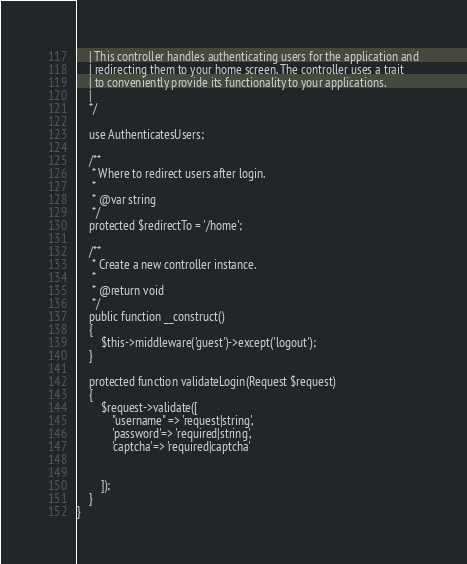Convert code to text. <code><loc_0><loc_0><loc_500><loc_500><_PHP_>    | This controller handles authenticating users for the application and
    | redirecting them to your home screen. The controller uses a trait
    | to conveniently provide its functionality to your applications.
    |
    */

    use AuthenticatesUsers;

    /**
     * Where to redirect users after login.
     *
     * @var string
     */
    protected $redirectTo = '/home';

    /**
     * Create a new controller instance.
     *
     * @return void
     */
    public function __construct()
    {
        $this->middleware('guest')->except('logout');
    }

    protected function validateLogin(Request $request)
    {
        $request->validate([
            "username" => 'request|string',
            'password'=> 'required|string',
            'captcha'=> 'required|captcha'

    
        ]);
    }
}
</code> 